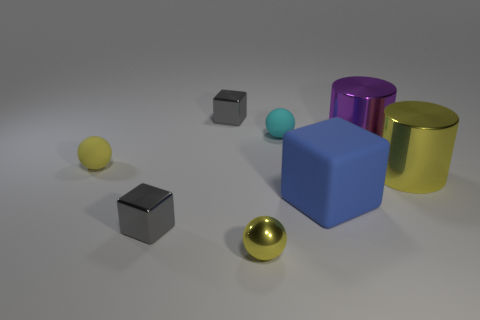Subtract all purple blocks. Subtract all blue spheres. How many blocks are left? 3 Add 2 tiny cyan objects. How many objects exist? 10 Subtract all balls. How many objects are left? 5 Add 4 cubes. How many cubes are left? 7 Add 1 yellow cylinders. How many yellow cylinders exist? 2 Subtract 1 yellow cylinders. How many objects are left? 7 Subtract all large gray matte cubes. Subtract all tiny yellow matte spheres. How many objects are left? 7 